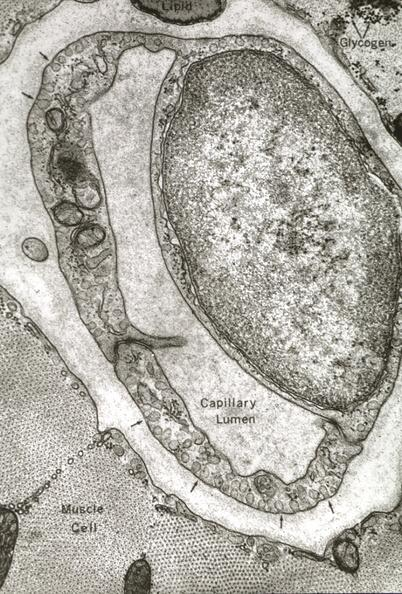does atrophy show skeletal muscle?
Answer the question using a single word or phrase. No 